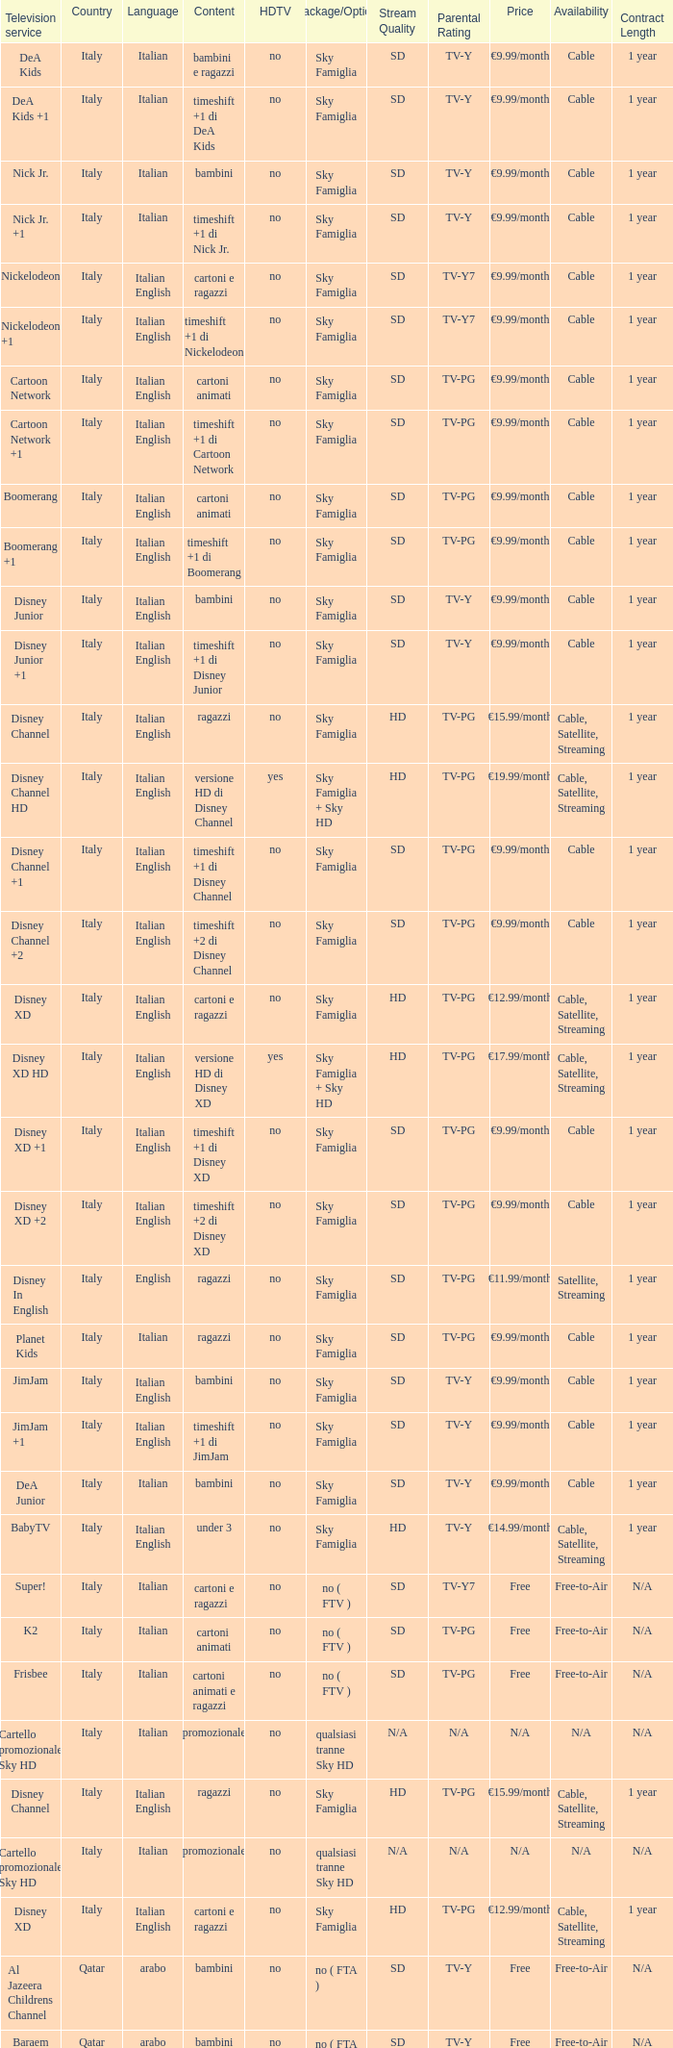What is the HDTV when the content shows a timeshift +1 di disney junior? No. 